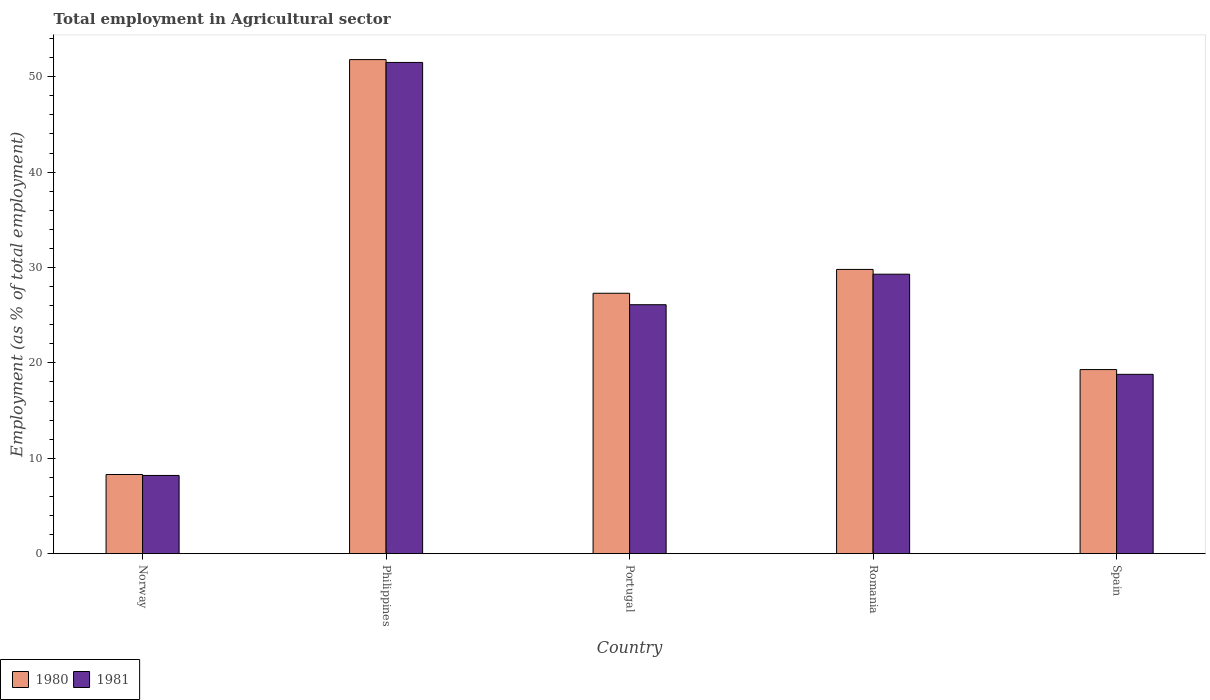How many groups of bars are there?
Provide a succinct answer. 5. Are the number of bars on each tick of the X-axis equal?
Your answer should be very brief. Yes. What is the label of the 3rd group of bars from the left?
Ensure brevity in your answer.  Portugal. What is the employment in agricultural sector in 1980 in Portugal?
Provide a succinct answer. 27.3. Across all countries, what is the maximum employment in agricultural sector in 1981?
Provide a succinct answer. 51.5. Across all countries, what is the minimum employment in agricultural sector in 1981?
Your answer should be very brief. 8.2. In which country was the employment in agricultural sector in 1981 maximum?
Ensure brevity in your answer.  Philippines. What is the total employment in agricultural sector in 1980 in the graph?
Offer a terse response. 136.5. What is the difference between the employment in agricultural sector in 1980 in Norway and the employment in agricultural sector in 1981 in Spain?
Your answer should be compact. -10.5. What is the average employment in agricultural sector in 1980 per country?
Provide a short and direct response. 27.3. What is the ratio of the employment in agricultural sector in 1980 in Norway to that in Romania?
Offer a terse response. 0.28. Is the difference between the employment in agricultural sector in 1980 in Portugal and Romania greater than the difference between the employment in agricultural sector in 1981 in Portugal and Romania?
Your answer should be very brief. Yes. What is the difference between the highest and the second highest employment in agricultural sector in 1980?
Keep it short and to the point. -24.5. What is the difference between the highest and the lowest employment in agricultural sector in 1981?
Offer a terse response. 43.3. How many bars are there?
Provide a short and direct response. 10. How many countries are there in the graph?
Offer a terse response. 5. What is the difference between two consecutive major ticks on the Y-axis?
Give a very brief answer. 10. Are the values on the major ticks of Y-axis written in scientific E-notation?
Your answer should be compact. No. Does the graph contain any zero values?
Offer a very short reply. No. What is the title of the graph?
Your answer should be very brief. Total employment in Agricultural sector. What is the label or title of the X-axis?
Your response must be concise. Country. What is the label or title of the Y-axis?
Your answer should be very brief. Employment (as % of total employment). What is the Employment (as % of total employment) of 1980 in Norway?
Keep it short and to the point. 8.3. What is the Employment (as % of total employment) of 1981 in Norway?
Give a very brief answer. 8.2. What is the Employment (as % of total employment) of 1980 in Philippines?
Offer a terse response. 51.8. What is the Employment (as % of total employment) of 1981 in Philippines?
Keep it short and to the point. 51.5. What is the Employment (as % of total employment) in 1980 in Portugal?
Keep it short and to the point. 27.3. What is the Employment (as % of total employment) of 1981 in Portugal?
Your answer should be compact. 26.1. What is the Employment (as % of total employment) in 1980 in Romania?
Keep it short and to the point. 29.8. What is the Employment (as % of total employment) in 1981 in Romania?
Keep it short and to the point. 29.3. What is the Employment (as % of total employment) of 1980 in Spain?
Provide a short and direct response. 19.3. What is the Employment (as % of total employment) of 1981 in Spain?
Make the answer very short. 18.8. Across all countries, what is the maximum Employment (as % of total employment) in 1980?
Ensure brevity in your answer.  51.8. Across all countries, what is the maximum Employment (as % of total employment) of 1981?
Provide a succinct answer. 51.5. Across all countries, what is the minimum Employment (as % of total employment) of 1980?
Provide a succinct answer. 8.3. Across all countries, what is the minimum Employment (as % of total employment) in 1981?
Offer a terse response. 8.2. What is the total Employment (as % of total employment) of 1980 in the graph?
Offer a very short reply. 136.5. What is the total Employment (as % of total employment) in 1981 in the graph?
Offer a terse response. 133.9. What is the difference between the Employment (as % of total employment) of 1980 in Norway and that in Philippines?
Your answer should be very brief. -43.5. What is the difference between the Employment (as % of total employment) of 1981 in Norway and that in Philippines?
Make the answer very short. -43.3. What is the difference between the Employment (as % of total employment) in 1980 in Norway and that in Portugal?
Ensure brevity in your answer.  -19. What is the difference between the Employment (as % of total employment) in 1981 in Norway and that in Portugal?
Provide a short and direct response. -17.9. What is the difference between the Employment (as % of total employment) in 1980 in Norway and that in Romania?
Give a very brief answer. -21.5. What is the difference between the Employment (as % of total employment) of 1981 in Norway and that in Romania?
Your response must be concise. -21.1. What is the difference between the Employment (as % of total employment) of 1980 in Norway and that in Spain?
Provide a short and direct response. -11. What is the difference between the Employment (as % of total employment) in 1981 in Philippines and that in Portugal?
Give a very brief answer. 25.4. What is the difference between the Employment (as % of total employment) of 1981 in Philippines and that in Romania?
Ensure brevity in your answer.  22.2. What is the difference between the Employment (as % of total employment) of 1980 in Philippines and that in Spain?
Offer a very short reply. 32.5. What is the difference between the Employment (as % of total employment) in 1981 in Philippines and that in Spain?
Provide a short and direct response. 32.7. What is the difference between the Employment (as % of total employment) in 1980 in Portugal and that in Romania?
Provide a succinct answer. -2.5. What is the difference between the Employment (as % of total employment) of 1981 in Portugal and that in Romania?
Your response must be concise. -3.2. What is the difference between the Employment (as % of total employment) of 1981 in Portugal and that in Spain?
Offer a terse response. 7.3. What is the difference between the Employment (as % of total employment) of 1980 in Norway and the Employment (as % of total employment) of 1981 in Philippines?
Keep it short and to the point. -43.2. What is the difference between the Employment (as % of total employment) in 1980 in Norway and the Employment (as % of total employment) in 1981 in Portugal?
Offer a very short reply. -17.8. What is the difference between the Employment (as % of total employment) in 1980 in Norway and the Employment (as % of total employment) in 1981 in Spain?
Your answer should be compact. -10.5. What is the difference between the Employment (as % of total employment) of 1980 in Philippines and the Employment (as % of total employment) of 1981 in Portugal?
Give a very brief answer. 25.7. What is the difference between the Employment (as % of total employment) in 1980 in Portugal and the Employment (as % of total employment) in 1981 in Romania?
Your answer should be very brief. -2. What is the average Employment (as % of total employment) of 1980 per country?
Keep it short and to the point. 27.3. What is the average Employment (as % of total employment) of 1981 per country?
Keep it short and to the point. 26.78. What is the difference between the Employment (as % of total employment) in 1980 and Employment (as % of total employment) in 1981 in Norway?
Ensure brevity in your answer.  0.1. What is the difference between the Employment (as % of total employment) of 1980 and Employment (as % of total employment) of 1981 in Philippines?
Give a very brief answer. 0.3. What is the ratio of the Employment (as % of total employment) in 1980 in Norway to that in Philippines?
Keep it short and to the point. 0.16. What is the ratio of the Employment (as % of total employment) in 1981 in Norway to that in Philippines?
Provide a succinct answer. 0.16. What is the ratio of the Employment (as % of total employment) of 1980 in Norway to that in Portugal?
Ensure brevity in your answer.  0.3. What is the ratio of the Employment (as % of total employment) in 1981 in Norway to that in Portugal?
Your answer should be very brief. 0.31. What is the ratio of the Employment (as % of total employment) of 1980 in Norway to that in Romania?
Ensure brevity in your answer.  0.28. What is the ratio of the Employment (as % of total employment) of 1981 in Norway to that in Romania?
Keep it short and to the point. 0.28. What is the ratio of the Employment (as % of total employment) of 1980 in Norway to that in Spain?
Ensure brevity in your answer.  0.43. What is the ratio of the Employment (as % of total employment) in 1981 in Norway to that in Spain?
Your answer should be very brief. 0.44. What is the ratio of the Employment (as % of total employment) in 1980 in Philippines to that in Portugal?
Offer a very short reply. 1.9. What is the ratio of the Employment (as % of total employment) of 1981 in Philippines to that in Portugal?
Make the answer very short. 1.97. What is the ratio of the Employment (as % of total employment) in 1980 in Philippines to that in Romania?
Give a very brief answer. 1.74. What is the ratio of the Employment (as % of total employment) in 1981 in Philippines to that in Romania?
Give a very brief answer. 1.76. What is the ratio of the Employment (as % of total employment) in 1980 in Philippines to that in Spain?
Provide a succinct answer. 2.68. What is the ratio of the Employment (as % of total employment) of 1981 in Philippines to that in Spain?
Keep it short and to the point. 2.74. What is the ratio of the Employment (as % of total employment) of 1980 in Portugal to that in Romania?
Your response must be concise. 0.92. What is the ratio of the Employment (as % of total employment) in 1981 in Portugal to that in Romania?
Make the answer very short. 0.89. What is the ratio of the Employment (as % of total employment) of 1980 in Portugal to that in Spain?
Your answer should be very brief. 1.41. What is the ratio of the Employment (as % of total employment) of 1981 in Portugal to that in Spain?
Your answer should be very brief. 1.39. What is the ratio of the Employment (as % of total employment) of 1980 in Romania to that in Spain?
Keep it short and to the point. 1.54. What is the ratio of the Employment (as % of total employment) of 1981 in Romania to that in Spain?
Ensure brevity in your answer.  1.56. What is the difference between the highest and the second highest Employment (as % of total employment) of 1980?
Make the answer very short. 22. What is the difference between the highest and the second highest Employment (as % of total employment) of 1981?
Your response must be concise. 22.2. What is the difference between the highest and the lowest Employment (as % of total employment) in 1980?
Ensure brevity in your answer.  43.5. What is the difference between the highest and the lowest Employment (as % of total employment) of 1981?
Make the answer very short. 43.3. 